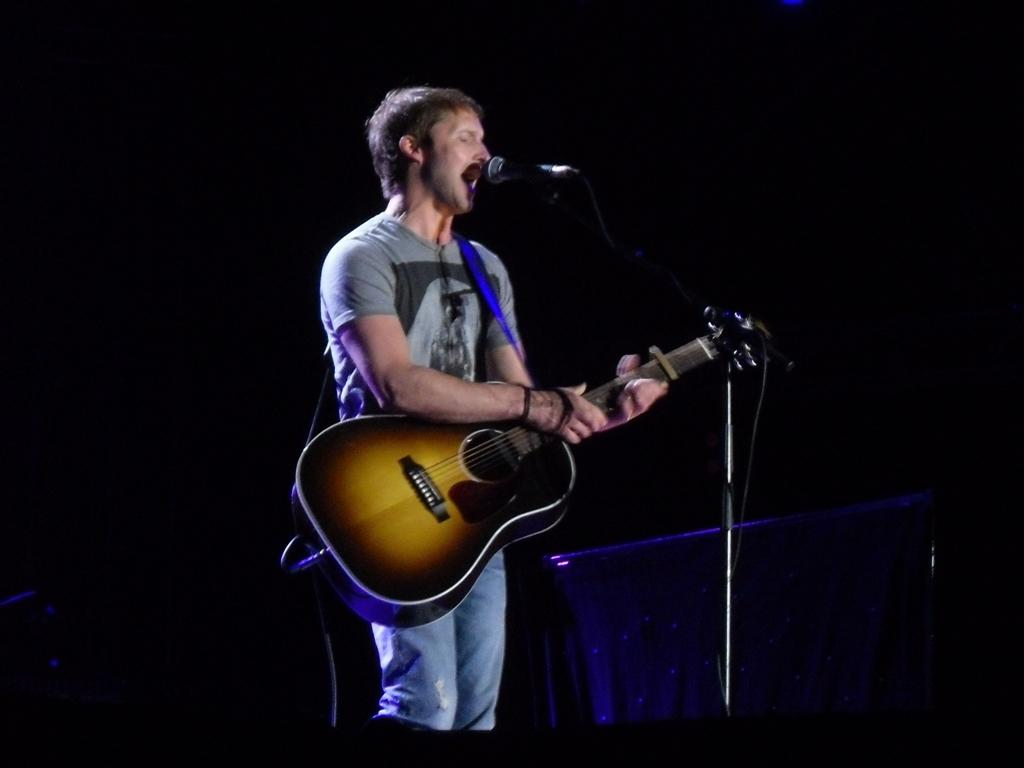What is the man in the image doing? The man is playing a guitar and singing. What object is in front of the man? There is a microphone in front of the man. What is the color of the background in the image? The background of the image is black. What type of instrument is the man inventing in the image? There is no indication in the image that the man is inventing any instrument; he is playing a guitar. What rhythm is the man following while playing the guitar in the image? The image does not provide information about the rhythm the man is following while playing the guitar. 